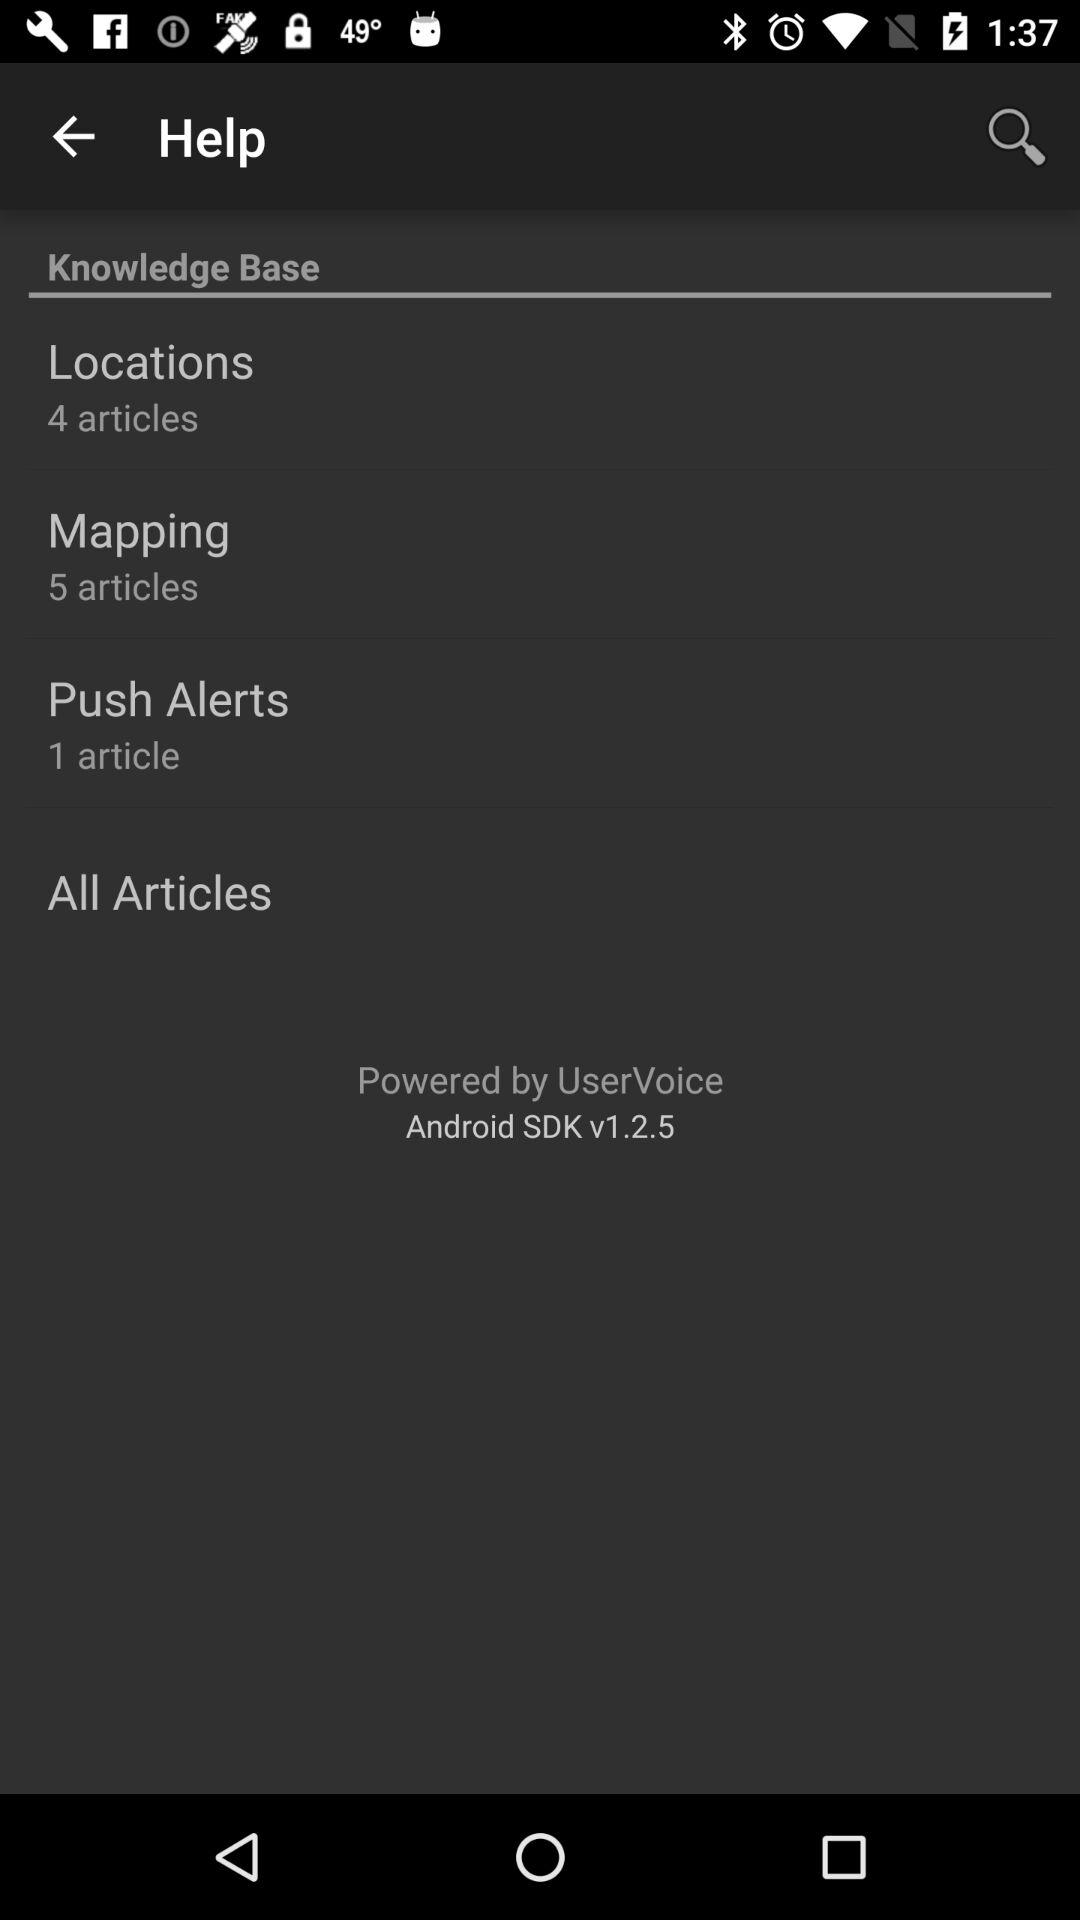Can you tell me what the other sections are and how many articles they include? Certainly! The 'Knowledge Base' has two other sections besides 'Push Alerts.' The 'Locations' section contains four articles, and the 'Mapping' section includes five articles, offering a range of information across different topics. 